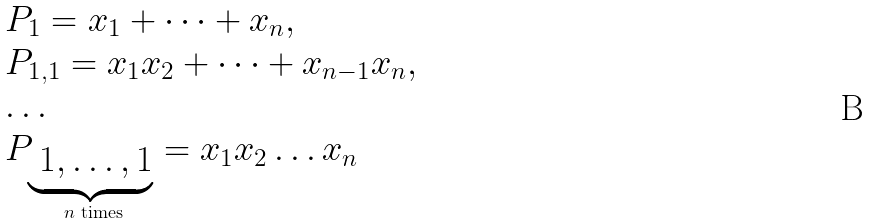Convert formula to latex. <formula><loc_0><loc_0><loc_500><loc_500>\begin{array} { l } P _ { 1 } = x _ { 1 } + \dots + x _ { n } , \\ P _ { 1 , 1 } = x _ { 1 } x _ { 2 } + \dots + x _ { n - 1 } x _ { n } , \\ \dots \\ P _ { \underbrace { \text { $1, \dots, 1$} } _ { \text { $n$ times} } } = x _ { 1 } x _ { 2 } \dots x _ { n } \end{array}</formula> 